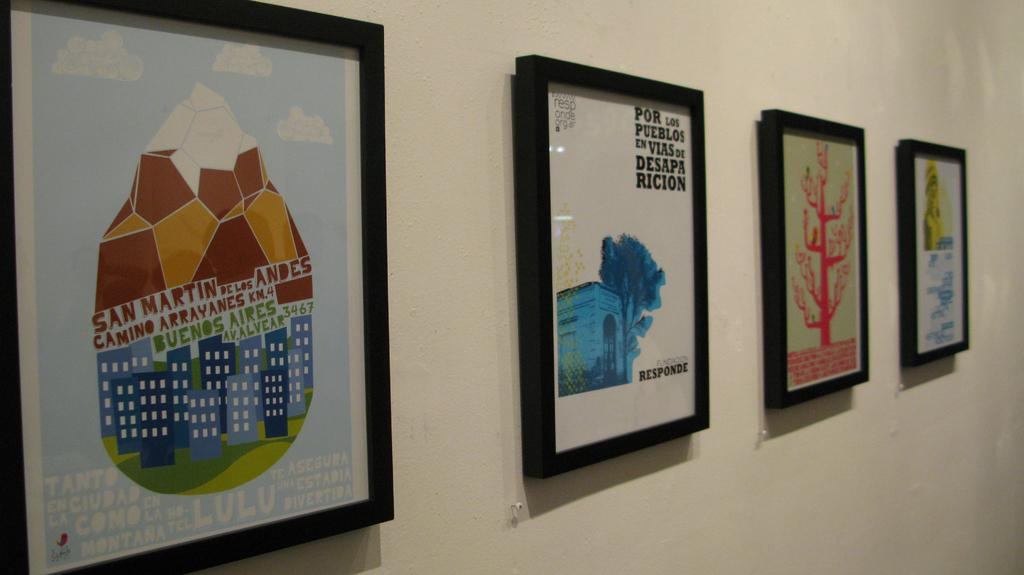Provide a one-sentence caption for the provided image. A picture with the message por los pueblos en vias de desapa ricion. 